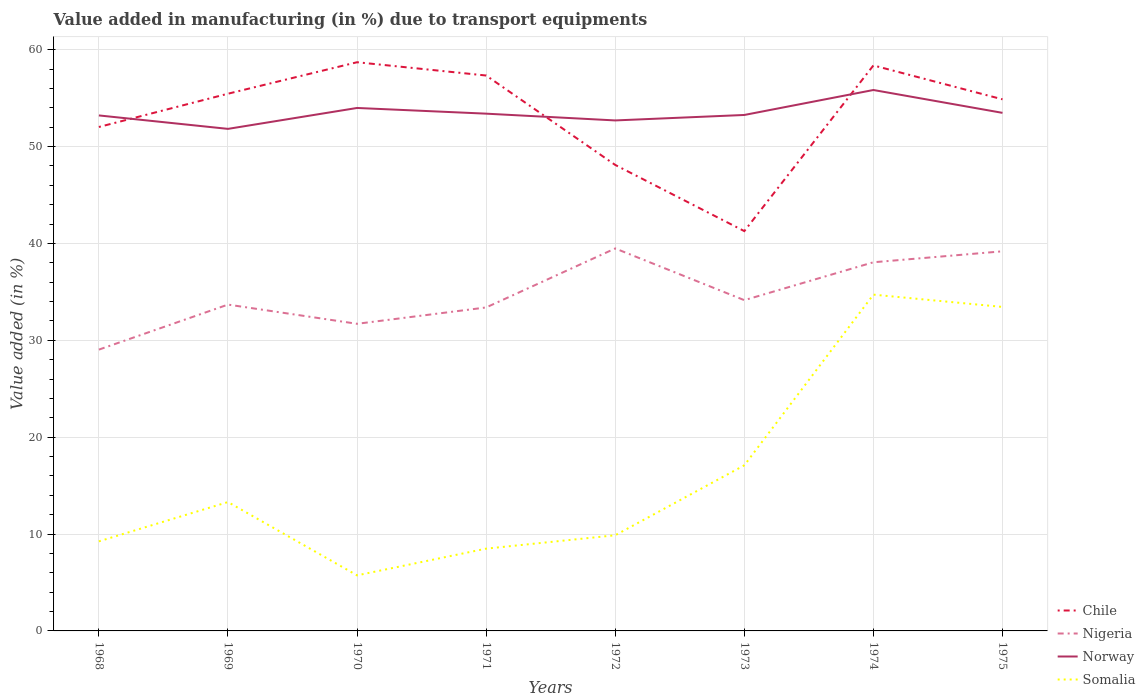Does the line corresponding to Norway intersect with the line corresponding to Nigeria?
Your answer should be very brief. No. Is the number of lines equal to the number of legend labels?
Give a very brief answer. Yes. Across all years, what is the maximum percentage of value added in manufacturing due to transport equipments in Norway?
Offer a terse response. 51.83. In which year was the percentage of value added in manufacturing due to transport equipments in Nigeria maximum?
Ensure brevity in your answer.  1968. What is the total percentage of value added in manufacturing due to transport equipments in Nigeria in the graph?
Your answer should be very brief. -2.67. What is the difference between the highest and the second highest percentage of value added in manufacturing due to transport equipments in Somalia?
Offer a terse response. 28.98. Is the percentage of value added in manufacturing due to transport equipments in Somalia strictly greater than the percentage of value added in manufacturing due to transport equipments in Nigeria over the years?
Your answer should be very brief. Yes. How many lines are there?
Your answer should be very brief. 4. What is the difference between two consecutive major ticks on the Y-axis?
Offer a terse response. 10. Are the values on the major ticks of Y-axis written in scientific E-notation?
Your answer should be compact. No. Does the graph contain any zero values?
Give a very brief answer. No. How are the legend labels stacked?
Offer a very short reply. Vertical. What is the title of the graph?
Offer a very short reply. Value added in manufacturing (in %) due to transport equipments. Does "Caribbean small states" appear as one of the legend labels in the graph?
Keep it short and to the point. No. What is the label or title of the Y-axis?
Your answer should be compact. Value added (in %). What is the Value added (in %) in Chile in 1968?
Keep it short and to the point. 52.03. What is the Value added (in %) of Nigeria in 1968?
Ensure brevity in your answer.  29.04. What is the Value added (in %) in Norway in 1968?
Your response must be concise. 53.22. What is the Value added (in %) in Somalia in 1968?
Make the answer very short. 9.25. What is the Value added (in %) of Chile in 1969?
Offer a very short reply. 55.46. What is the Value added (in %) in Nigeria in 1969?
Keep it short and to the point. 33.69. What is the Value added (in %) of Norway in 1969?
Provide a short and direct response. 51.83. What is the Value added (in %) in Somalia in 1969?
Provide a short and direct response. 13.3. What is the Value added (in %) in Chile in 1970?
Give a very brief answer. 58.71. What is the Value added (in %) in Nigeria in 1970?
Provide a succinct answer. 31.71. What is the Value added (in %) in Norway in 1970?
Your response must be concise. 53.99. What is the Value added (in %) of Somalia in 1970?
Give a very brief answer. 5.74. What is the Value added (in %) in Chile in 1971?
Your response must be concise. 57.34. What is the Value added (in %) in Nigeria in 1971?
Keep it short and to the point. 33.4. What is the Value added (in %) in Norway in 1971?
Offer a very short reply. 53.4. What is the Value added (in %) of Somalia in 1971?
Your answer should be very brief. 8.49. What is the Value added (in %) in Chile in 1972?
Provide a short and direct response. 48.11. What is the Value added (in %) of Nigeria in 1972?
Keep it short and to the point. 39.49. What is the Value added (in %) of Norway in 1972?
Give a very brief answer. 52.7. What is the Value added (in %) of Somalia in 1972?
Make the answer very short. 9.88. What is the Value added (in %) of Chile in 1973?
Make the answer very short. 41.28. What is the Value added (in %) of Nigeria in 1973?
Provide a succinct answer. 34.15. What is the Value added (in %) of Norway in 1973?
Provide a succinct answer. 53.27. What is the Value added (in %) in Somalia in 1973?
Your response must be concise. 17.1. What is the Value added (in %) of Chile in 1974?
Provide a succinct answer. 58.38. What is the Value added (in %) in Nigeria in 1974?
Ensure brevity in your answer.  38.06. What is the Value added (in %) in Norway in 1974?
Provide a succinct answer. 55.84. What is the Value added (in %) in Somalia in 1974?
Your answer should be very brief. 34.72. What is the Value added (in %) in Chile in 1975?
Offer a terse response. 54.88. What is the Value added (in %) of Nigeria in 1975?
Your answer should be very brief. 39.19. What is the Value added (in %) of Norway in 1975?
Your answer should be very brief. 53.49. What is the Value added (in %) of Somalia in 1975?
Make the answer very short. 33.45. Across all years, what is the maximum Value added (in %) in Chile?
Offer a very short reply. 58.71. Across all years, what is the maximum Value added (in %) in Nigeria?
Make the answer very short. 39.49. Across all years, what is the maximum Value added (in %) in Norway?
Ensure brevity in your answer.  55.84. Across all years, what is the maximum Value added (in %) of Somalia?
Ensure brevity in your answer.  34.72. Across all years, what is the minimum Value added (in %) in Chile?
Make the answer very short. 41.28. Across all years, what is the minimum Value added (in %) in Nigeria?
Provide a short and direct response. 29.04. Across all years, what is the minimum Value added (in %) in Norway?
Offer a terse response. 51.83. Across all years, what is the minimum Value added (in %) of Somalia?
Offer a terse response. 5.74. What is the total Value added (in %) in Chile in the graph?
Your answer should be compact. 426.19. What is the total Value added (in %) of Nigeria in the graph?
Your answer should be very brief. 278.72. What is the total Value added (in %) of Norway in the graph?
Ensure brevity in your answer.  427.75. What is the total Value added (in %) of Somalia in the graph?
Your response must be concise. 131.92. What is the difference between the Value added (in %) of Chile in 1968 and that in 1969?
Ensure brevity in your answer.  -3.44. What is the difference between the Value added (in %) of Nigeria in 1968 and that in 1969?
Your answer should be very brief. -4.65. What is the difference between the Value added (in %) in Norway in 1968 and that in 1969?
Give a very brief answer. 1.39. What is the difference between the Value added (in %) in Somalia in 1968 and that in 1969?
Give a very brief answer. -4.06. What is the difference between the Value added (in %) of Chile in 1968 and that in 1970?
Ensure brevity in your answer.  -6.69. What is the difference between the Value added (in %) of Nigeria in 1968 and that in 1970?
Make the answer very short. -2.67. What is the difference between the Value added (in %) in Norway in 1968 and that in 1970?
Make the answer very short. -0.77. What is the difference between the Value added (in %) in Somalia in 1968 and that in 1970?
Offer a very short reply. 3.51. What is the difference between the Value added (in %) of Chile in 1968 and that in 1971?
Your answer should be very brief. -5.31. What is the difference between the Value added (in %) of Nigeria in 1968 and that in 1971?
Offer a terse response. -4.35. What is the difference between the Value added (in %) in Norway in 1968 and that in 1971?
Make the answer very short. -0.18. What is the difference between the Value added (in %) of Somalia in 1968 and that in 1971?
Ensure brevity in your answer.  0.75. What is the difference between the Value added (in %) of Chile in 1968 and that in 1972?
Your response must be concise. 3.92. What is the difference between the Value added (in %) in Nigeria in 1968 and that in 1972?
Provide a succinct answer. -10.44. What is the difference between the Value added (in %) in Norway in 1968 and that in 1972?
Offer a terse response. 0.52. What is the difference between the Value added (in %) in Somalia in 1968 and that in 1972?
Provide a short and direct response. -0.63. What is the difference between the Value added (in %) of Chile in 1968 and that in 1973?
Keep it short and to the point. 10.75. What is the difference between the Value added (in %) of Nigeria in 1968 and that in 1973?
Give a very brief answer. -5.11. What is the difference between the Value added (in %) in Norway in 1968 and that in 1973?
Give a very brief answer. -0.05. What is the difference between the Value added (in %) of Somalia in 1968 and that in 1973?
Provide a succinct answer. -7.85. What is the difference between the Value added (in %) in Chile in 1968 and that in 1974?
Your answer should be compact. -6.36. What is the difference between the Value added (in %) in Nigeria in 1968 and that in 1974?
Offer a very short reply. -9.02. What is the difference between the Value added (in %) in Norway in 1968 and that in 1974?
Provide a succinct answer. -2.63. What is the difference between the Value added (in %) of Somalia in 1968 and that in 1974?
Your response must be concise. -25.47. What is the difference between the Value added (in %) in Chile in 1968 and that in 1975?
Provide a short and direct response. -2.86. What is the difference between the Value added (in %) in Nigeria in 1968 and that in 1975?
Provide a succinct answer. -10.15. What is the difference between the Value added (in %) of Norway in 1968 and that in 1975?
Offer a terse response. -0.27. What is the difference between the Value added (in %) of Somalia in 1968 and that in 1975?
Offer a very short reply. -24.2. What is the difference between the Value added (in %) in Chile in 1969 and that in 1970?
Give a very brief answer. -3.25. What is the difference between the Value added (in %) in Nigeria in 1969 and that in 1970?
Provide a short and direct response. 1.98. What is the difference between the Value added (in %) of Norway in 1969 and that in 1970?
Make the answer very short. -2.16. What is the difference between the Value added (in %) of Somalia in 1969 and that in 1970?
Offer a terse response. 7.57. What is the difference between the Value added (in %) of Chile in 1969 and that in 1971?
Your answer should be very brief. -1.88. What is the difference between the Value added (in %) in Nigeria in 1969 and that in 1971?
Make the answer very short. 0.29. What is the difference between the Value added (in %) of Norway in 1969 and that in 1971?
Keep it short and to the point. -1.57. What is the difference between the Value added (in %) of Somalia in 1969 and that in 1971?
Your response must be concise. 4.81. What is the difference between the Value added (in %) of Chile in 1969 and that in 1972?
Ensure brevity in your answer.  7.35. What is the difference between the Value added (in %) in Nigeria in 1969 and that in 1972?
Your answer should be compact. -5.8. What is the difference between the Value added (in %) of Norway in 1969 and that in 1972?
Make the answer very short. -0.87. What is the difference between the Value added (in %) of Somalia in 1969 and that in 1972?
Your answer should be very brief. 3.43. What is the difference between the Value added (in %) in Chile in 1969 and that in 1973?
Provide a short and direct response. 14.18. What is the difference between the Value added (in %) in Nigeria in 1969 and that in 1973?
Offer a terse response. -0.46. What is the difference between the Value added (in %) of Norway in 1969 and that in 1973?
Your answer should be compact. -1.44. What is the difference between the Value added (in %) in Somalia in 1969 and that in 1973?
Your answer should be very brief. -3.79. What is the difference between the Value added (in %) in Chile in 1969 and that in 1974?
Your answer should be very brief. -2.92. What is the difference between the Value added (in %) in Nigeria in 1969 and that in 1974?
Offer a very short reply. -4.37. What is the difference between the Value added (in %) of Norway in 1969 and that in 1974?
Your response must be concise. -4.01. What is the difference between the Value added (in %) in Somalia in 1969 and that in 1974?
Ensure brevity in your answer.  -21.41. What is the difference between the Value added (in %) of Chile in 1969 and that in 1975?
Your response must be concise. 0.58. What is the difference between the Value added (in %) of Nigeria in 1969 and that in 1975?
Ensure brevity in your answer.  -5.5. What is the difference between the Value added (in %) in Norway in 1969 and that in 1975?
Provide a succinct answer. -1.65. What is the difference between the Value added (in %) of Somalia in 1969 and that in 1975?
Keep it short and to the point. -20.15. What is the difference between the Value added (in %) in Chile in 1970 and that in 1971?
Give a very brief answer. 1.37. What is the difference between the Value added (in %) in Nigeria in 1970 and that in 1971?
Ensure brevity in your answer.  -1.69. What is the difference between the Value added (in %) in Norway in 1970 and that in 1971?
Make the answer very short. 0.59. What is the difference between the Value added (in %) in Somalia in 1970 and that in 1971?
Your response must be concise. -2.76. What is the difference between the Value added (in %) in Chile in 1970 and that in 1972?
Provide a short and direct response. 10.6. What is the difference between the Value added (in %) in Nigeria in 1970 and that in 1972?
Your answer should be compact. -7.78. What is the difference between the Value added (in %) in Norway in 1970 and that in 1972?
Provide a short and direct response. 1.29. What is the difference between the Value added (in %) in Somalia in 1970 and that in 1972?
Your response must be concise. -4.14. What is the difference between the Value added (in %) in Chile in 1970 and that in 1973?
Your answer should be compact. 17.43. What is the difference between the Value added (in %) in Nigeria in 1970 and that in 1973?
Your response must be concise. -2.44. What is the difference between the Value added (in %) of Norway in 1970 and that in 1973?
Ensure brevity in your answer.  0.72. What is the difference between the Value added (in %) in Somalia in 1970 and that in 1973?
Your response must be concise. -11.36. What is the difference between the Value added (in %) of Chile in 1970 and that in 1974?
Offer a very short reply. 0.33. What is the difference between the Value added (in %) in Nigeria in 1970 and that in 1974?
Keep it short and to the point. -6.35. What is the difference between the Value added (in %) of Norway in 1970 and that in 1974?
Keep it short and to the point. -1.85. What is the difference between the Value added (in %) in Somalia in 1970 and that in 1974?
Your response must be concise. -28.98. What is the difference between the Value added (in %) of Chile in 1970 and that in 1975?
Give a very brief answer. 3.83. What is the difference between the Value added (in %) of Nigeria in 1970 and that in 1975?
Offer a terse response. -7.48. What is the difference between the Value added (in %) in Norway in 1970 and that in 1975?
Your answer should be compact. 0.51. What is the difference between the Value added (in %) of Somalia in 1970 and that in 1975?
Provide a short and direct response. -27.71. What is the difference between the Value added (in %) in Chile in 1971 and that in 1972?
Keep it short and to the point. 9.23. What is the difference between the Value added (in %) of Nigeria in 1971 and that in 1972?
Your answer should be very brief. -6.09. What is the difference between the Value added (in %) in Norway in 1971 and that in 1972?
Offer a very short reply. 0.7. What is the difference between the Value added (in %) in Somalia in 1971 and that in 1972?
Your response must be concise. -1.38. What is the difference between the Value added (in %) in Chile in 1971 and that in 1973?
Your response must be concise. 16.06. What is the difference between the Value added (in %) of Nigeria in 1971 and that in 1973?
Your answer should be very brief. -0.75. What is the difference between the Value added (in %) of Norway in 1971 and that in 1973?
Ensure brevity in your answer.  0.14. What is the difference between the Value added (in %) of Somalia in 1971 and that in 1973?
Provide a short and direct response. -8.6. What is the difference between the Value added (in %) of Chile in 1971 and that in 1974?
Give a very brief answer. -1.04. What is the difference between the Value added (in %) of Nigeria in 1971 and that in 1974?
Your answer should be very brief. -4.67. What is the difference between the Value added (in %) in Norway in 1971 and that in 1974?
Offer a terse response. -2.44. What is the difference between the Value added (in %) of Somalia in 1971 and that in 1974?
Offer a terse response. -26.22. What is the difference between the Value added (in %) in Chile in 1971 and that in 1975?
Your answer should be very brief. 2.46. What is the difference between the Value added (in %) of Nigeria in 1971 and that in 1975?
Make the answer very short. -5.8. What is the difference between the Value added (in %) of Norway in 1971 and that in 1975?
Give a very brief answer. -0.08. What is the difference between the Value added (in %) in Somalia in 1971 and that in 1975?
Your answer should be very brief. -24.96. What is the difference between the Value added (in %) of Chile in 1972 and that in 1973?
Make the answer very short. 6.83. What is the difference between the Value added (in %) in Nigeria in 1972 and that in 1973?
Your answer should be very brief. 5.34. What is the difference between the Value added (in %) of Norway in 1972 and that in 1973?
Offer a terse response. -0.56. What is the difference between the Value added (in %) of Somalia in 1972 and that in 1973?
Give a very brief answer. -7.22. What is the difference between the Value added (in %) in Chile in 1972 and that in 1974?
Ensure brevity in your answer.  -10.27. What is the difference between the Value added (in %) in Nigeria in 1972 and that in 1974?
Give a very brief answer. 1.43. What is the difference between the Value added (in %) of Norway in 1972 and that in 1974?
Keep it short and to the point. -3.14. What is the difference between the Value added (in %) in Somalia in 1972 and that in 1974?
Provide a succinct answer. -24.84. What is the difference between the Value added (in %) in Chile in 1972 and that in 1975?
Your response must be concise. -6.77. What is the difference between the Value added (in %) of Nigeria in 1972 and that in 1975?
Keep it short and to the point. 0.3. What is the difference between the Value added (in %) in Norway in 1972 and that in 1975?
Your response must be concise. -0.78. What is the difference between the Value added (in %) of Somalia in 1972 and that in 1975?
Ensure brevity in your answer.  -23.57. What is the difference between the Value added (in %) in Chile in 1973 and that in 1974?
Offer a terse response. -17.1. What is the difference between the Value added (in %) in Nigeria in 1973 and that in 1974?
Your response must be concise. -3.91. What is the difference between the Value added (in %) of Norway in 1973 and that in 1974?
Make the answer very short. -2.58. What is the difference between the Value added (in %) of Somalia in 1973 and that in 1974?
Make the answer very short. -17.62. What is the difference between the Value added (in %) in Chile in 1973 and that in 1975?
Your answer should be compact. -13.6. What is the difference between the Value added (in %) of Nigeria in 1973 and that in 1975?
Ensure brevity in your answer.  -5.04. What is the difference between the Value added (in %) in Norway in 1973 and that in 1975?
Offer a very short reply. -0.22. What is the difference between the Value added (in %) of Somalia in 1973 and that in 1975?
Your answer should be compact. -16.35. What is the difference between the Value added (in %) in Chile in 1974 and that in 1975?
Make the answer very short. 3.5. What is the difference between the Value added (in %) of Nigeria in 1974 and that in 1975?
Your answer should be very brief. -1.13. What is the difference between the Value added (in %) in Norway in 1974 and that in 1975?
Your answer should be very brief. 2.36. What is the difference between the Value added (in %) of Somalia in 1974 and that in 1975?
Your answer should be compact. 1.27. What is the difference between the Value added (in %) in Chile in 1968 and the Value added (in %) in Nigeria in 1969?
Provide a short and direct response. 18.34. What is the difference between the Value added (in %) in Chile in 1968 and the Value added (in %) in Norway in 1969?
Provide a succinct answer. 0.19. What is the difference between the Value added (in %) of Chile in 1968 and the Value added (in %) of Somalia in 1969?
Your response must be concise. 38.72. What is the difference between the Value added (in %) of Nigeria in 1968 and the Value added (in %) of Norway in 1969?
Make the answer very short. -22.79. What is the difference between the Value added (in %) in Nigeria in 1968 and the Value added (in %) in Somalia in 1969?
Keep it short and to the point. 15.74. What is the difference between the Value added (in %) in Norway in 1968 and the Value added (in %) in Somalia in 1969?
Give a very brief answer. 39.92. What is the difference between the Value added (in %) in Chile in 1968 and the Value added (in %) in Nigeria in 1970?
Offer a terse response. 20.32. What is the difference between the Value added (in %) of Chile in 1968 and the Value added (in %) of Norway in 1970?
Your response must be concise. -1.96. What is the difference between the Value added (in %) in Chile in 1968 and the Value added (in %) in Somalia in 1970?
Ensure brevity in your answer.  46.29. What is the difference between the Value added (in %) of Nigeria in 1968 and the Value added (in %) of Norway in 1970?
Your answer should be compact. -24.95. What is the difference between the Value added (in %) in Nigeria in 1968 and the Value added (in %) in Somalia in 1970?
Your answer should be compact. 23.31. What is the difference between the Value added (in %) in Norway in 1968 and the Value added (in %) in Somalia in 1970?
Offer a very short reply. 47.48. What is the difference between the Value added (in %) of Chile in 1968 and the Value added (in %) of Nigeria in 1971?
Your answer should be compact. 18.63. What is the difference between the Value added (in %) in Chile in 1968 and the Value added (in %) in Norway in 1971?
Give a very brief answer. -1.38. What is the difference between the Value added (in %) of Chile in 1968 and the Value added (in %) of Somalia in 1971?
Your answer should be very brief. 43.53. What is the difference between the Value added (in %) of Nigeria in 1968 and the Value added (in %) of Norway in 1971?
Your answer should be compact. -24.36. What is the difference between the Value added (in %) of Nigeria in 1968 and the Value added (in %) of Somalia in 1971?
Your answer should be very brief. 20.55. What is the difference between the Value added (in %) of Norway in 1968 and the Value added (in %) of Somalia in 1971?
Your answer should be compact. 44.73. What is the difference between the Value added (in %) in Chile in 1968 and the Value added (in %) in Nigeria in 1972?
Keep it short and to the point. 12.54. What is the difference between the Value added (in %) in Chile in 1968 and the Value added (in %) in Norway in 1972?
Your answer should be compact. -0.68. What is the difference between the Value added (in %) in Chile in 1968 and the Value added (in %) in Somalia in 1972?
Keep it short and to the point. 42.15. What is the difference between the Value added (in %) of Nigeria in 1968 and the Value added (in %) of Norway in 1972?
Make the answer very short. -23.66. What is the difference between the Value added (in %) in Nigeria in 1968 and the Value added (in %) in Somalia in 1972?
Your response must be concise. 19.17. What is the difference between the Value added (in %) in Norway in 1968 and the Value added (in %) in Somalia in 1972?
Ensure brevity in your answer.  43.34. What is the difference between the Value added (in %) of Chile in 1968 and the Value added (in %) of Nigeria in 1973?
Make the answer very short. 17.88. What is the difference between the Value added (in %) of Chile in 1968 and the Value added (in %) of Norway in 1973?
Ensure brevity in your answer.  -1.24. What is the difference between the Value added (in %) in Chile in 1968 and the Value added (in %) in Somalia in 1973?
Provide a succinct answer. 34.93. What is the difference between the Value added (in %) in Nigeria in 1968 and the Value added (in %) in Norway in 1973?
Keep it short and to the point. -24.22. What is the difference between the Value added (in %) in Nigeria in 1968 and the Value added (in %) in Somalia in 1973?
Offer a terse response. 11.94. What is the difference between the Value added (in %) of Norway in 1968 and the Value added (in %) of Somalia in 1973?
Offer a very short reply. 36.12. What is the difference between the Value added (in %) of Chile in 1968 and the Value added (in %) of Nigeria in 1974?
Make the answer very short. 13.97. What is the difference between the Value added (in %) in Chile in 1968 and the Value added (in %) in Norway in 1974?
Your response must be concise. -3.82. What is the difference between the Value added (in %) in Chile in 1968 and the Value added (in %) in Somalia in 1974?
Your response must be concise. 17.31. What is the difference between the Value added (in %) in Nigeria in 1968 and the Value added (in %) in Norway in 1974?
Make the answer very short. -26.8. What is the difference between the Value added (in %) in Nigeria in 1968 and the Value added (in %) in Somalia in 1974?
Offer a very short reply. -5.68. What is the difference between the Value added (in %) in Norway in 1968 and the Value added (in %) in Somalia in 1974?
Your answer should be compact. 18.5. What is the difference between the Value added (in %) of Chile in 1968 and the Value added (in %) of Nigeria in 1975?
Provide a succinct answer. 12.84. What is the difference between the Value added (in %) of Chile in 1968 and the Value added (in %) of Norway in 1975?
Give a very brief answer. -1.46. What is the difference between the Value added (in %) in Chile in 1968 and the Value added (in %) in Somalia in 1975?
Provide a succinct answer. 18.58. What is the difference between the Value added (in %) of Nigeria in 1968 and the Value added (in %) of Norway in 1975?
Make the answer very short. -24.44. What is the difference between the Value added (in %) of Nigeria in 1968 and the Value added (in %) of Somalia in 1975?
Provide a short and direct response. -4.41. What is the difference between the Value added (in %) of Norway in 1968 and the Value added (in %) of Somalia in 1975?
Your response must be concise. 19.77. What is the difference between the Value added (in %) in Chile in 1969 and the Value added (in %) in Nigeria in 1970?
Your response must be concise. 23.75. What is the difference between the Value added (in %) in Chile in 1969 and the Value added (in %) in Norway in 1970?
Make the answer very short. 1.47. What is the difference between the Value added (in %) in Chile in 1969 and the Value added (in %) in Somalia in 1970?
Provide a short and direct response. 49.73. What is the difference between the Value added (in %) in Nigeria in 1969 and the Value added (in %) in Norway in 1970?
Keep it short and to the point. -20.3. What is the difference between the Value added (in %) in Nigeria in 1969 and the Value added (in %) in Somalia in 1970?
Ensure brevity in your answer.  27.95. What is the difference between the Value added (in %) in Norway in 1969 and the Value added (in %) in Somalia in 1970?
Provide a short and direct response. 46.1. What is the difference between the Value added (in %) of Chile in 1969 and the Value added (in %) of Nigeria in 1971?
Keep it short and to the point. 22.07. What is the difference between the Value added (in %) in Chile in 1969 and the Value added (in %) in Norway in 1971?
Make the answer very short. 2.06. What is the difference between the Value added (in %) in Chile in 1969 and the Value added (in %) in Somalia in 1971?
Offer a very short reply. 46.97. What is the difference between the Value added (in %) of Nigeria in 1969 and the Value added (in %) of Norway in 1971?
Offer a very short reply. -19.71. What is the difference between the Value added (in %) of Nigeria in 1969 and the Value added (in %) of Somalia in 1971?
Give a very brief answer. 25.2. What is the difference between the Value added (in %) in Norway in 1969 and the Value added (in %) in Somalia in 1971?
Give a very brief answer. 43.34. What is the difference between the Value added (in %) in Chile in 1969 and the Value added (in %) in Nigeria in 1972?
Provide a succinct answer. 15.98. What is the difference between the Value added (in %) in Chile in 1969 and the Value added (in %) in Norway in 1972?
Your answer should be compact. 2.76. What is the difference between the Value added (in %) in Chile in 1969 and the Value added (in %) in Somalia in 1972?
Your response must be concise. 45.58. What is the difference between the Value added (in %) in Nigeria in 1969 and the Value added (in %) in Norway in 1972?
Your answer should be very brief. -19.01. What is the difference between the Value added (in %) of Nigeria in 1969 and the Value added (in %) of Somalia in 1972?
Your answer should be very brief. 23.81. What is the difference between the Value added (in %) in Norway in 1969 and the Value added (in %) in Somalia in 1972?
Offer a very short reply. 41.95. What is the difference between the Value added (in %) in Chile in 1969 and the Value added (in %) in Nigeria in 1973?
Provide a succinct answer. 21.31. What is the difference between the Value added (in %) of Chile in 1969 and the Value added (in %) of Norway in 1973?
Make the answer very short. 2.2. What is the difference between the Value added (in %) of Chile in 1969 and the Value added (in %) of Somalia in 1973?
Provide a short and direct response. 38.36. What is the difference between the Value added (in %) in Nigeria in 1969 and the Value added (in %) in Norway in 1973?
Keep it short and to the point. -19.58. What is the difference between the Value added (in %) in Nigeria in 1969 and the Value added (in %) in Somalia in 1973?
Keep it short and to the point. 16.59. What is the difference between the Value added (in %) in Norway in 1969 and the Value added (in %) in Somalia in 1973?
Keep it short and to the point. 34.73. What is the difference between the Value added (in %) of Chile in 1969 and the Value added (in %) of Nigeria in 1974?
Keep it short and to the point. 17.4. What is the difference between the Value added (in %) of Chile in 1969 and the Value added (in %) of Norway in 1974?
Your answer should be very brief. -0.38. What is the difference between the Value added (in %) in Chile in 1969 and the Value added (in %) in Somalia in 1974?
Provide a short and direct response. 20.74. What is the difference between the Value added (in %) of Nigeria in 1969 and the Value added (in %) of Norway in 1974?
Ensure brevity in your answer.  -22.15. What is the difference between the Value added (in %) in Nigeria in 1969 and the Value added (in %) in Somalia in 1974?
Your answer should be very brief. -1.03. What is the difference between the Value added (in %) in Norway in 1969 and the Value added (in %) in Somalia in 1974?
Offer a very short reply. 17.11. What is the difference between the Value added (in %) in Chile in 1969 and the Value added (in %) in Nigeria in 1975?
Your response must be concise. 16.27. What is the difference between the Value added (in %) in Chile in 1969 and the Value added (in %) in Norway in 1975?
Provide a succinct answer. 1.98. What is the difference between the Value added (in %) in Chile in 1969 and the Value added (in %) in Somalia in 1975?
Provide a succinct answer. 22.01. What is the difference between the Value added (in %) of Nigeria in 1969 and the Value added (in %) of Norway in 1975?
Make the answer very short. -19.8. What is the difference between the Value added (in %) of Nigeria in 1969 and the Value added (in %) of Somalia in 1975?
Keep it short and to the point. 0.24. What is the difference between the Value added (in %) of Norway in 1969 and the Value added (in %) of Somalia in 1975?
Provide a succinct answer. 18.38. What is the difference between the Value added (in %) of Chile in 1970 and the Value added (in %) of Nigeria in 1971?
Give a very brief answer. 25.32. What is the difference between the Value added (in %) in Chile in 1970 and the Value added (in %) in Norway in 1971?
Offer a terse response. 5.31. What is the difference between the Value added (in %) in Chile in 1970 and the Value added (in %) in Somalia in 1971?
Make the answer very short. 50.22. What is the difference between the Value added (in %) in Nigeria in 1970 and the Value added (in %) in Norway in 1971?
Give a very brief answer. -21.69. What is the difference between the Value added (in %) of Nigeria in 1970 and the Value added (in %) of Somalia in 1971?
Ensure brevity in your answer.  23.21. What is the difference between the Value added (in %) in Norway in 1970 and the Value added (in %) in Somalia in 1971?
Your answer should be compact. 45.5. What is the difference between the Value added (in %) of Chile in 1970 and the Value added (in %) of Nigeria in 1972?
Offer a very short reply. 19.23. What is the difference between the Value added (in %) of Chile in 1970 and the Value added (in %) of Norway in 1972?
Your answer should be very brief. 6.01. What is the difference between the Value added (in %) of Chile in 1970 and the Value added (in %) of Somalia in 1972?
Provide a succinct answer. 48.83. What is the difference between the Value added (in %) in Nigeria in 1970 and the Value added (in %) in Norway in 1972?
Make the answer very short. -21. What is the difference between the Value added (in %) of Nigeria in 1970 and the Value added (in %) of Somalia in 1972?
Your answer should be very brief. 21.83. What is the difference between the Value added (in %) in Norway in 1970 and the Value added (in %) in Somalia in 1972?
Provide a succinct answer. 44.11. What is the difference between the Value added (in %) of Chile in 1970 and the Value added (in %) of Nigeria in 1973?
Your answer should be very brief. 24.56. What is the difference between the Value added (in %) of Chile in 1970 and the Value added (in %) of Norway in 1973?
Your answer should be compact. 5.45. What is the difference between the Value added (in %) of Chile in 1970 and the Value added (in %) of Somalia in 1973?
Offer a very short reply. 41.61. What is the difference between the Value added (in %) of Nigeria in 1970 and the Value added (in %) of Norway in 1973?
Your answer should be very brief. -21.56. What is the difference between the Value added (in %) in Nigeria in 1970 and the Value added (in %) in Somalia in 1973?
Give a very brief answer. 14.61. What is the difference between the Value added (in %) of Norway in 1970 and the Value added (in %) of Somalia in 1973?
Offer a very short reply. 36.89. What is the difference between the Value added (in %) of Chile in 1970 and the Value added (in %) of Nigeria in 1974?
Make the answer very short. 20.65. What is the difference between the Value added (in %) of Chile in 1970 and the Value added (in %) of Norway in 1974?
Your response must be concise. 2.87. What is the difference between the Value added (in %) of Chile in 1970 and the Value added (in %) of Somalia in 1974?
Give a very brief answer. 23.99. What is the difference between the Value added (in %) of Nigeria in 1970 and the Value added (in %) of Norway in 1974?
Your answer should be very brief. -24.14. What is the difference between the Value added (in %) of Nigeria in 1970 and the Value added (in %) of Somalia in 1974?
Your answer should be very brief. -3.01. What is the difference between the Value added (in %) of Norway in 1970 and the Value added (in %) of Somalia in 1974?
Offer a terse response. 19.27. What is the difference between the Value added (in %) in Chile in 1970 and the Value added (in %) in Nigeria in 1975?
Offer a very short reply. 19.52. What is the difference between the Value added (in %) of Chile in 1970 and the Value added (in %) of Norway in 1975?
Your answer should be compact. 5.23. What is the difference between the Value added (in %) in Chile in 1970 and the Value added (in %) in Somalia in 1975?
Provide a succinct answer. 25.26. What is the difference between the Value added (in %) in Nigeria in 1970 and the Value added (in %) in Norway in 1975?
Give a very brief answer. -21.78. What is the difference between the Value added (in %) in Nigeria in 1970 and the Value added (in %) in Somalia in 1975?
Your answer should be compact. -1.74. What is the difference between the Value added (in %) of Norway in 1970 and the Value added (in %) of Somalia in 1975?
Your answer should be very brief. 20.54. What is the difference between the Value added (in %) of Chile in 1971 and the Value added (in %) of Nigeria in 1972?
Your response must be concise. 17.85. What is the difference between the Value added (in %) in Chile in 1971 and the Value added (in %) in Norway in 1972?
Provide a short and direct response. 4.64. What is the difference between the Value added (in %) of Chile in 1971 and the Value added (in %) of Somalia in 1972?
Offer a terse response. 47.46. What is the difference between the Value added (in %) in Nigeria in 1971 and the Value added (in %) in Norway in 1972?
Ensure brevity in your answer.  -19.31. What is the difference between the Value added (in %) in Nigeria in 1971 and the Value added (in %) in Somalia in 1972?
Offer a very short reply. 23.52. What is the difference between the Value added (in %) of Norway in 1971 and the Value added (in %) of Somalia in 1972?
Ensure brevity in your answer.  43.52. What is the difference between the Value added (in %) in Chile in 1971 and the Value added (in %) in Nigeria in 1973?
Ensure brevity in your answer.  23.19. What is the difference between the Value added (in %) in Chile in 1971 and the Value added (in %) in Norway in 1973?
Provide a short and direct response. 4.07. What is the difference between the Value added (in %) in Chile in 1971 and the Value added (in %) in Somalia in 1973?
Offer a terse response. 40.24. What is the difference between the Value added (in %) in Nigeria in 1971 and the Value added (in %) in Norway in 1973?
Ensure brevity in your answer.  -19.87. What is the difference between the Value added (in %) of Nigeria in 1971 and the Value added (in %) of Somalia in 1973?
Offer a very short reply. 16.3. What is the difference between the Value added (in %) in Norway in 1971 and the Value added (in %) in Somalia in 1973?
Offer a terse response. 36.3. What is the difference between the Value added (in %) of Chile in 1971 and the Value added (in %) of Nigeria in 1974?
Keep it short and to the point. 19.28. What is the difference between the Value added (in %) of Chile in 1971 and the Value added (in %) of Norway in 1974?
Your answer should be compact. 1.5. What is the difference between the Value added (in %) of Chile in 1971 and the Value added (in %) of Somalia in 1974?
Keep it short and to the point. 22.62. What is the difference between the Value added (in %) in Nigeria in 1971 and the Value added (in %) in Norway in 1974?
Your response must be concise. -22.45. What is the difference between the Value added (in %) in Nigeria in 1971 and the Value added (in %) in Somalia in 1974?
Make the answer very short. -1.32. What is the difference between the Value added (in %) in Norway in 1971 and the Value added (in %) in Somalia in 1974?
Ensure brevity in your answer.  18.68. What is the difference between the Value added (in %) of Chile in 1971 and the Value added (in %) of Nigeria in 1975?
Provide a succinct answer. 18.15. What is the difference between the Value added (in %) in Chile in 1971 and the Value added (in %) in Norway in 1975?
Your answer should be compact. 3.85. What is the difference between the Value added (in %) in Chile in 1971 and the Value added (in %) in Somalia in 1975?
Make the answer very short. 23.89. What is the difference between the Value added (in %) of Nigeria in 1971 and the Value added (in %) of Norway in 1975?
Make the answer very short. -20.09. What is the difference between the Value added (in %) in Nigeria in 1971 and the Value added (in %) in Somalia in 1975?
Give a very brief answer. -0.05. What is the difference between the Value added (in %) of Norway in 1971 and the Value added (in %) of Somalia in 1975?
Offer a very short reply. 19.95. What is the difference between the Value added (in %) of Chile in 1972 and the Value added (in %) of Nigeria in 1973?
Offer a very short reply. 13.96. What is the difference between the Value added (in %) in Chile in 1972 and the Value added (in %) in Norway in 1973?
Provide a short and direct response. -5.16. What is the difference between the Value added (in %) of Chile in 1972 and the Value added (in %) of Somalia in 1973?
Keep it short and to the point. 31.01. What is the difference between the Value added (in %) of Nigeria in 1972 and the Value added (in %) of Norway in 1973?
Provide a short and direct response. -13.78. What is the difference between the Value added (in %) in Nigeria in 1972 and the Value added (in %) in Somalia in 1973?
Make the answer very short. 22.39. What is the difference between the Value added (in %) in Norway in 1972 and the Value added (in %) in Somalia in 1973?
Your answer should be very brief. 35.61. What is the difference between the Value added (in %) in Chile in 1972 and the Value added (in %) in Nigeria in 1974?
Make the answer very short. 10.05. What is the difference between the Value added (in %) in Chile in 1972 and the Value added (in %) in Norway in 1974?
Your answer should be compact. -7.74. What is the difference between the Value added (in %) in Chile in 1972 and the Value added (in %) in Somalia in 1974?
Provide a short and direct response. 13.39. What is the difference between the Value added (in %) of Nigeria in 1972 and the Value added (in %) of Norway in 1974?
Provide a short and direct response. -16.36. What is the difference between the Value added (in %) in Nigeria in 1972 and the Value added (in %) in Somalia in 1974?
Keep it short and to the point. 4.77. What is the difference between the Value added (in %) of Norway in 1972 and the Value added (in %) of Somalia in 1974?
Provide a succinct answer. 17.99. What is the difference between the Value added (in %) of Chile in 1972 and the Value added (in %) of Nigeria in 1975?
Your answer should be very brief. 8.92. What is the difference between the Value added (in %) of Chile in 1972 and the Value added (in %) of Norway in 1975?
Keep it short and to the point. -5.38. What is the difference between the Value added (in %) in Chile in 1972 and the Value added (in %) in Somalia in 1975?
Your answer should be compact. 14.66. What is the difference between the Value added (in %) of Nigeria in 1972 and the Value added (in %) of Norway in 1975?
Provide a short and direct response. -14. What is the difference between the Value added (in %) of Nigeria in 1972 and the Value added (in %) of Somalia in 1975?
Your answer should be very brief. 6.04. What is the difference between the Value added (in %) of Norway in 1972 and the Value added (in %) of Somalia in 1975?
Your answer should be compact. 19.25. What is the difference between the Value added (in %) of Chile in 1973 and the Value added (in %) of Nigeria in 1974?
Your answer should be compact. 3.22. What is the difference between the Value added (in %) of Chile in 1973 and the Value added (in %) of Norway in 1974?
Offer a very short reply. -14.57. What is the difference between the Value added (in %) in Chile in 1973 and the Value added (in %) in Somalia in 1974?
Provide a short and direct response. 6.56. What is the difference between the Value added (in %) of Nigeria in 1973 and the Value added (in %) of Norway in 1974?
Provide a short and direct response. -21.7. What is the difference between the Value added (in %) of Nigeria in 1973 and the Value added (in %) of Somalia in 1974?
Ensure brevity in your answer.  -0.57. What is the difference between the Value added (in %) in Norway in 1973 and the Value added (in %) in Somalia in 1974?
Offer a very short reply. 18.55. What is the difference between the Value added (in %) in Chile in 1973 and the Value added (in %) in Nigeria in 1975?
Make the answer very short. 2.09. What is the difference between the Value added (in %) in Chile in 1973 and the Value added (in %) in Norway in 1975?
Keep it short and to the point. -12.21. What is the difference between the Value added (in %) of Chile in 1973 and the Value added (in %) of Somalia in 1975?
Make the answer very short. 7.83. What is the difference between the Value added (in %) in Nigeria in 1973 and the Value added (in %) in Norway in 1975?
Your answer should be compact. -19.34. What is the difference between the Value added (in %) of Nigeria in 1973 and the Value added (in %) of Somalia in 1975?
Ensure brevity in your answer.  0.7. What is the difference between the Value added (in %) in Norway in 1973 and the Value added (in %) in Somalia in 1975?
Offer a very short reply. 19.82. What is the difference between the Value added (in %) of Chile in 1974 and the Value added (in %) of Nigeria in 1975?
Provide a succinct answer. 19.19. What is the difference between the Value added (in %) in Chile in 1974 and the Value added (in %) in Norway in 1975?
Your response must be concise. 4.9. What is the difference between the Value added (in %) in Chile in 1974 and the Value added (in %) in Somalia in 1975?
Offer a very short reply. 24.93. What is the difference between the Value added (in %) of Nigeria in 1974 and the Value added (in %) of Norway in 1975?
Ensure brevity in your answer.  -15.43. What is the difference between the Value added (in %) in Nigeria in 1974 and the Value added (in %) in Somalia in 1975?
Provide a short and direct response. 4.61. What is the difference between the Value added (in %) of Norway in 1974 and the Value added (in %) of Somalia in 1975?
Give a very brief answer. 22.4. What is the average Value added (in %) of Chile per year?
Offer a terse response. 53.27. What is the average Value added (in %) of Nigeria per year?
Offer a terse response. 34.84. What is the average Value added (in %) in Norway per year?
Provide a succinct answer. 53.47. What is the average Value added (in %) in Somalia per year?
Make the answer very short. 16.49. In the year 1968, what is the difference between the Value added (in %) in Chile and Value added (in %) in Nigeria?
Give a very brief answer. 22.98. In the year 1968, what is the difference between the Value added (in %) of Chile and Value added (in %) of Norway?
Make the answer very short. -1.19. In the year 1968, what is the difference between the Value added (in %) of Chile and Value added (in %) of Somalia?
Your answer should be compact. 42.78. In the year 1968, what is the difference between the Value added (in %) of Nigeria and Value added (in %) of Norway?
Offer a very short reply. -24.18. In the year 1968, what is the difference between the Value added (in %) of Nigeria and Value added (in %) of Somalia?
Provide a short and direct response. 19.8. In the year 1968, what is the difference between the Value added (in %) in Norway and Value added (in %) in Somalia?
Your answer should be compact. 43.97. In the year 1969, what is the difference between the Value added (in %) in Chile and Value added (in %) in Nigeria?
Offer a terse response. 21.77. In the year 1969, what is the difference between the Value added (in %) in Chile and Value added (in %) in Norway?
Your response must be concise. 3.63. In the year 1969, what is the difference between the Value added (in %) in Chile and Value added (in %) in Somalia?
Provide a succinct answer. 42.16. In the year 1969, what is the difference between the Value added (in %) in Nigeria and Value added (in %) in Norway?
Your answer should be compact. -18.14. In the year 1969, what is the difference between the Value added (in %) of Nigeria and Value added (in %) of Somalia?
Give a very brief answer. 20.39. In the year 1969, what is the difference between the Value added (in %) in Norway and Value added (in %) in Somalia?
Ensure brevity in your answer.  38.53. In the year 1970, what is the difference between the Value added (in %) of Chile and Value added (in %) of Nigeria?
Provide a succinct answer. 27. In the year 1970, what is the difference between the Value added (in %) in Chile and Value added (in %) in Norway?
Ensure brevity in your answer.  4.72. In the year 1970, what is the difference between the Value added (in %) of Chile and Value added (in %) of Somalia?
Make the answer very short. 52.98. In the year 1970, what is the difference between the Value added (in %) in Nigeria and Value added (in %) in Norway?
Make the answer very short. -22.28. In the year 1970, what is the difference between the Value added (in %) in Nigeria and Value added (in %) in Somalia?
Your answer should be compact. 25.97. In the year 1970, what is the difference between the Value added (in %) of Norway and Value added (in %) of Somalia?
Ensure brevity in your answer.  48.25. In the year 1971, what is the difference between the Value added (in %) in Chile and Value added (in %) in Nigeria?
Ensure brevity in your answer.  23.95. In the year 1971, what is the difference between the Value added (in %) of Chile and Value added (in %) of Norway?
Offer a very short reply. 3.94. In the year 1971, what is the difference between the Value added (in %) in Chile and Value added (in %) in Somalia?
Make the answer very short. 48.85. In the year 1971, what is the difference between the Value added (in %) of Nigeria and Value added (in %) of Norway?
Provide a short and direct response. -20.01. In the year 1971, what is the difference between the Value added (in %) of Nigeria and Value added (in %) of Somalia?
Make the answer very short. 24.9. In the year 1971, what is the difference between the Value added (in %) in Norway and Value added (in %) in Somalia?
Give a very brief answer. 44.91. In the year 1972, what is the difference between the Value added (in %) of Chile and Value added (in %) of Nigeria?
Provide a short and direct response. 8.62. In the year 1972, what is the difference between the Value added (in %) of Chile and Value added (in %) of Norway?
Ensure brevity in your answer.  -4.6. In the year 1972, what is the difference between the Value added (in %) of Chile and Value added (in %) of Somalia?
Your answer should be compact. 38.23. In the year 1972, what is the difference between the Value added (in %) of Nigeria and Value added (in %) of Norway?
Your answer should be compact. -13.22. In the year 1972, what is the difference between the Value added (in %) of Nigeria and Value added (in %) of Somalia?
Provide a succinct answer. 29.61. In the year 1972, what is the difference between the Value added (in %) in Norway and Value added (in %) in Somalia?
Your response must be concise. 42.83. In the year 1973, what is the difference between the Value added (in %) in Chile and Value added (in %) in Nigeria?
Give a very brief answer. 7.13. In the year 1973, what is the difference between the Value added (in %) of Chile and Value added (in %) of Norway?
Your response must be concise. -11.99. In the year 1973, what is the difference between the Value added (in %) of Chile and Value added (in %) of Somalia?
Offer a terse response. 24.18. In the year 1973, what is the difference between the Value added (in %) in Nigeria and Value added (in %) in Norway?
Your answer should be compact. -19.12. In the year 1973, what is the difference between the Value added (in %) of Nigeria and Value added (in %) of Somalia?
Offer a very short reply. 17.05. In the year 1973, what is the difference between the Value added (in %) of Norway and Value added (in %) of Somalia?
Provide a succinct answer. 36.17. In the year 1974, what is the difference between the Value added (in %) in Chile and Value added (in %) in Nigeria?
Your answer should be compact. 20.32. In the year 1974, what is the difference between the Value added (in %) of Chile and Value added (in %) of Norway?
Offer a terse response. 2.54. In the year 1974, what is the difference between the Value added (in %) in Chile and Value added (in %) in Somalia?
Give a very brief answer. 23.66. In the year 1974, what is the difference between the Value added (in %) of Nigeria and Value added (in %) of Norway?
Offer a very short reply. -17.78. In the year 1974, what is the difference between the Value added (in %) in Nigeria and Value added (in %) in Somalia?
Ensure brevity in your answer.  3.34. In the year 1974, what is the difference between the Value added (in %) in Norway and Value added (in %) in Somalia?
Your answer should be compact. 21.13. In the year 1975, what is the difference between the Value added (in %) of Chile and Value added (in %) of Nigeria?
Ensure brevity in your answer.  15.69. In the year 1975, what is the difference between the Value added (in %) in Chile and Value added (in %) in Norway?
Make the answer very short. 1.4. In the year 1975, what is the difference between the Value added (in %) in Chile and Value added (in %) in Somalia?
Provide a short and direct response. 21.43. In the year 1975, what is the difference between the Value added (in %) in Nigeria and Value added (in %) in Norway?
Ensure brevity in your answer.  -14.29. In the year 1975, what is the difference between the Value added (in %) of Nigeria and Value added (in %) of Somalia?
Offer a terse response. 5.74. In the year 1975, what is the difference between the Value added (in %) in Norway and Value added (in %) in Somalia?
Your answer should be very brief. 20.04. What is the ratio of the Value added (in %) in Chile in 1968 to that in 1969?
Your response must be concise. 0.94. What is the ratio of the Value added (in %) in Nigeria in 1968 to that in 1969?
Offer a terse response. 0.86. What is the ratio of the Value added (in %) of Norway in 1968 to that in 1969?
Offer a very short reply. 1.03. What is the ratio of the Value added (in %) in Somalia in 1968 to that in 1969?
Provide a succinct answer. 0.69. What is the ratio of the Value added (in %) of Chile in 1968 to that in 1970?
Provide a short and direct response. 0.89. What is the ratio of the Value added (in %) of Nigeria in 1968 to that in 1970?
Your response must be concise. 0.92. What is the ratio of the Value added (in %) in Norway in 1968 to that in 1970?
Offer a terse response. 0.99. What is the ratio of the Value added (in %) of Somalia in 1968 to that in 1970?
Provide a succinct answer. 1.61. What is the ratio of the Value added (in %) in Chile in 1968 to that in 1971?
Your answer should be compact. 0.91. What is the ratio of the Value added (in %) of Nigeria in 1968 to that in 1971?
Your answer should be compact. 0.87. What is the ratio of the Value added (in %) of Somalia in 1968 to that in 1971?
Provide a succinct answer. 1.09. What is the ratio of the Value added (in %) of Chile in 1968 to that in 1972?
Ensure brevity in your answer.  1.08. What is the ratio of the Value added (in %) of Nigeria in 1968 to that in 1972?
Your answer should be compact. 0.74. What is the ratio of the Value added (in %) of Norway in 1968 to that in 1972?
Your response must be concise. 1.01. What is the ratio of the Value added (in %) of Somalia in 1968 to that in 1972?
Offer a very short reply. 0.94. What is the ratio of the Value added (in %) of Chile in 1968 to that in 1973?
Your answer should be very brief. 1.26. What is the ratio of the Value added (in %) of Nigeria in 1968 to that in 1973?
Your answer should be very brief. 0.85. What is the ratio of the Value added (in %) of Norway in 1968 to that in 1973?
Give a very brief answer. 1. What is the ratio of the Value added (in %) in Somalia in 1968 to that in 1973?
Give a very brief answer. 0.54. What is the ratio of the Value added (in %) of Chile in 1968 to that in 1974?
Your answer should be very brief. 0.89. What is the ratio of the Value added (in %) in Nigeria in 1968 to that in 1974?
Make the answer very short. 0.76. What is the ratio of the Value added (in %) in Norway in 1968 to that in 1974?
Your answer should be compact. 0.95. What is the ratio of the Value added (in %) of Somalia in 1968 to that in 1974?
Provide a short and direct response. 0.27. What is the ratio of the Value added (in %) of Chile in 1968 to that in 1975?
Make the answer very short. 0.95. What is the ratio of the Value added (in %) in Nigeria in 1968 to that in 1975?
Provide a short and direct response. 0.74. What is the ratio of the Value added (in %) of Norway in 1968 to that in 1975?
Provide a short and direct response. 0.99. What is the ratio of the Value added (in %) of Somalia in 1968 to that in 1975?
Your answer should be very brief. 0.28. What is the ratio of the Value added (in %) in Chile in 1969 to that in 1970?
Offer a terse response. 0.94. What is the ratio of the Value added (in %) of Nigeria in 1969 to that in 1970?
Offer a terse response. 1.06. What is the ratio of the Value added (in %) in Somalia in 1969 to that in 1970?
Your response must be concise. 2.32. What is the ratio of the Value added (in %) in Chile in 1969 to that in 1971?
Your answer should be compact. 0.97. What is the ratio of the Value added (in %) of Nigeria in 1969 to that in 1971?
Give a very brief answer. 1.01. What is the ratio of the Value added (in %) in Norway in 1969 to that in 1971?
Your answer should be compact. 0.97. What is the ratio of the Value added (in %) of Somalia in 1969 to that in 1971?
Your answer should be compact. 1.57. What is the ratio of the Value added (in %) of Chile in 1969 to that in 1972?
Your response must be concise. 1.15. What is the ratio of the Value added (in %) in Nigeria in 1969 to that in 1972?
Your answer should be very brief. 0.85. What is the ratio of the Value added (in %) of Norway in 1969 to that in 1972?
Offer a very short reply. 0.98. What is the ratio of the Value added (in %) in Somalia in 1969 to that in 1972?
Offer a very short reply. 1.35. What is the ratio of the Value added (in %) of Chile in 1969 to that in 1973?
Ensure brevity in your answer.  1.34. What is the ratio of the Value added (in %) of Nigeria in 1969 to that in 1973?
Your answer should be compact. 0.99. What is the ratio of the Value added (in %) in Norway in 1969 to that in 1973?
Offer a terse response. 0.97. What is the ratio of the Value added (in %) of Somalia in 1969 to that in 1973?
Offer a terse response. 0.78. What is the ratio of the Value added (in %) in Chile in 1969 to that in 1974?
Your answer should be very brief. 0.95. What is the ratio of the Value added (in %) of Nigeria in 1969 to that in 1974?
Your answer should be compact. 0.89. What is the ratio of the Value added (in %) of Norway in 1969 to that in 1974?
Give a very brief answer. 0.93. What is the ratio of the Value added (in %) in Somalia in 1969 to that in 1974?
Ensure brevity in your answer.  0.38. What is the ratio of the Value added (in %) of Chile in 1969 to that in 1975?
Ensure brevity in your answer.  1.01. What is the ratio of the Value added (in %) of Nigeria in 1969 to that in 1975?
Give a very brief answer. 0.86. What is the ratio of the Value added (in %) in Norway in 1969 to that in 1975?
Offer a very short reply. 0.97. What is the ratio of the Value added (in %) in Somalia in 1969 to that in 1975?
Your answer should be very brief. 0.4. What is the ratio of the Value added (in %) in Chile in 1970 to that in 1971?
Make the answer very short. 1.02. What is the ratio of the Value added (in %) of Nigeria in 1970 to that in 1971?
Keep it short and to the point. 0.95. What is the ratio of the Value added (in %) in Norway in 1970 to that in 1971?
Ensure brevity in your answer.  1.01. What is the ratio of the Value added (in %) of Somalia in 1970 to that in 1971?
Provide a short and direct response. 0.68. What is the ratio of the Value added (in %) in Chile in 1970 to that in 1972?
Provide a succinct answer. 1.22. What is the ratio of the Value added (in %) of Nigeria in 1970 to that in 1972?
Provide a short and direct response. 0.8. What is the ratio of the Value added (in %) in Norway in 1970 to that in 1972?
Give a very brief answer. 1.02. What is the ratio of the Value added (in %) in Somalia in 1970 to that in 1972?
Your response must be concise. 0.58. What is the ratio of the Value added (in %) in Chile in 1970 to that in 1973?
Give a very brief answer. 1.42. What is the ratio of the Value added (in %) in Nigeria in 1970 to that in 1973?
Provide a short and direct response. 0.93. What is the ratio of the Value added (in %) of Norway in 1970 to that in 1973?
Offer a very short reply. 1.01. What is the ratio of the Value added (in %) of Somalia in 1970 to that in 1973?
Make the answer very short. 0.34. What is the ratio of the Value added (in %) of Nigeria in 1970 to that in 1974?
Your answer should be compact. 0.83. What is the ratio of the Value added (in %) in Norway in 1970 to that in 1974?
Give a very brief answer. 0.97. What is the ratio of the Value added (in %) in Somalia in 1970 to that in 1974?
Your answer should be compact. 0.17. What is the ratio of the Value added (in %) in Chile in 1970 to that in 1975?
Your response must be concise. 1.07. What is the ratio of the Value added (in %) in Nigeria in 1970 to that in 1975?
Offer a terse response. 0.81. What is the ratio of the Value added (in %) of Norway in 1970 to that in 1975?
Provide a short and direct response. 1.01. What is the ratio of the Value added (in %) of Somalia in 1970 to that in 1975?
Offer a very short reply. 0.17. What is the ratio of the Value added (in %) of Chile in 1971 to that in 1972?
Give a very brief answer. 1.19. What is the ratio of the Value added (in %) in Nigeria in 1971 to that in 1972?
Your response must be concise. 0.85. What is the ratio of the Value added (in %) in Norway in 1971 to that in 1972?
Give a very brief answer. 1.01. What is the ratio of the Value added (in %) of Somalia in 1971 to that in 1972?
Your response must be concise. 0.86. What is the ratio of the Value added (in %) of Chile in 1971 to that in 1973?
Offer a terse response. 1.39. What is the ratio of the Value added (in %) in Nigeria in 1971 to that in 1973?
Your response must be concise. 0.98. What is the ratio of the Value added (in %) of Somalia in 1971 to that in 1973?
Ensure brevity in your answer.  0.5. What is the ratio of the Value added (in %) in Chile in 1971 to that in 1974?
Offer a very short reply. 0.98. What is the ratio of the Value added (in %) of Nigeria in 1971 to that in 1974?
Ensure brevity in your answer.  0.88. What is the ratio of the Value added (in %) of Norway in 1971 to that in 1974?
Provide a succinct answer. 0.96. What is the ratio of the Value added (in %) of Somalia in 1971 to that in 1974?
Provide a succinct answer. 0.24. What is the ratio of the Value added (in %) of Chile in 1971 to that in 1975?
Your answer should be very brief. 1.04. What is the ratio of the Value added (in %) of Nigeria in 1971 to that in 1975?
Give a very brief answer. 0.85. What is the ratio of the Value added (in %) in Somalia in 1971 to that in 1975?
Your response must be concise. 0.25. What is the ratio of the Value added (in %) of Chile in 1972 to that in 1973?
Give a very brief answer. 1.17. What is the ratio of the Value added (in %) of Nigeria in 1972 to that in 1973?
Provide a succinct answer. 1.16. What is the ratio of the Value added (in %) in Somalia in 1972 to that in 1973?
Provide a succinct answer. 0.58. What is the ratio of the Value added (in %) in Chile in 1972 to that in 1974?
Make the answer very short. 0.82. What is the ratio of the Value added (in %) of Nigeria in 1972 to that in 1974?
Provide a short and direct response. 1.04. What is the ratio of the Value added (in %) in Norway in 1972 to that in 1974?
Offer a very short reply. 0.94. What is the ratio of the Value added (in %) in Somalia in 1972 to that in 1974?
Ensure brevity in your answer.  0.28. What is the ratio of the Value added (in %) of Chile in 1972 to that in 1975?
Offer a very short reply. 0.88. What is the ratio of the Value added (in %) in Nigeria in 1972 to that in 1975?
Your response must be concise. 1.01. What is the ratio of the Value added (in %) in Norway in 1972 to that in 1975?
Make the answer very short. 0.99. What is the ratio of the Value added (in %) in Somalia in 1972 to that in 1975?
Provide a short and direct response. 0.3. What is the ratio of the Value added (in %) in Chile in 1973 to that in 1974?
Offer a terse response. 0.71. What is the ratio of the Value added (in %) in Nigeria in 1973 to that in 1974?
Your answer should be compact. 0.9. What is the ratio of the Value added (in %) in Norway in 1973 to that in 1974?
Your response must be concise. 0.95. What is the ratio of the Value added (in %) of Somalia in 1973 to that in 1974?
Give a very brief answer. 0.49. What is the ratio of the Value added (in %) of Chile in 1973 to that in 1975?
Keep it short and to the point. 0.75. What is the ratio of the Value added (in %) in Nigeria in 1973 to that in 1975?
Ensure brevity in your answer.  0.87. What is the ratio of the Value added (in %) of Somalia in 1973 to that in 1975?
Provide a succinct answer. 0.51. What is the ratio of the Value added (in %) of Chile in 1974 to that in 1975?
Ensure brevity in your answer.  1.06. What is the ratio of the Value added (in %) of Nigeria in 1974 to that in 1975?
Make the answer very short. 0.97. What is the ratio of the Value added (in %) in Norway in 1974 to that in 1975?
Keep it short and to the point. 1.04. What is the ratio of the Value added (in %) in Somalia in 1974 to that in 1975?
Keep it short and to the point. 1.04. What is the difference between the highest and the second highest Value added (in %) in Chile?
Your answer should be compact. 0.33. What is the difference between the highest and the second highest Value added (in %) in Nigeria?
Provide a succinct answer. 0.3. What is the difference between the highest and the second highest Value added (in %) of Norway?
Offer a very short reply. 1.85. What is the difference between the highest and the second highest Value added (in %) of Somalia?
Provide a succinct answer. 1.27. What is the difference between the highest and the lowest Value added (in %) in Chile?
Your answer should be compact. 17.43. What is the difference between the highest and the lowest Value added (in %) of Nigeria?
Ensure brevity in your answer.  10.44. What is the difference between the highest and the lowest Value added (in %) of Norway?
Provide a short and direct response. 4.01. What is the difference between the highest and the lowest Value added (in %) in Somalia?
Your answer should be very brief. 28.98. 